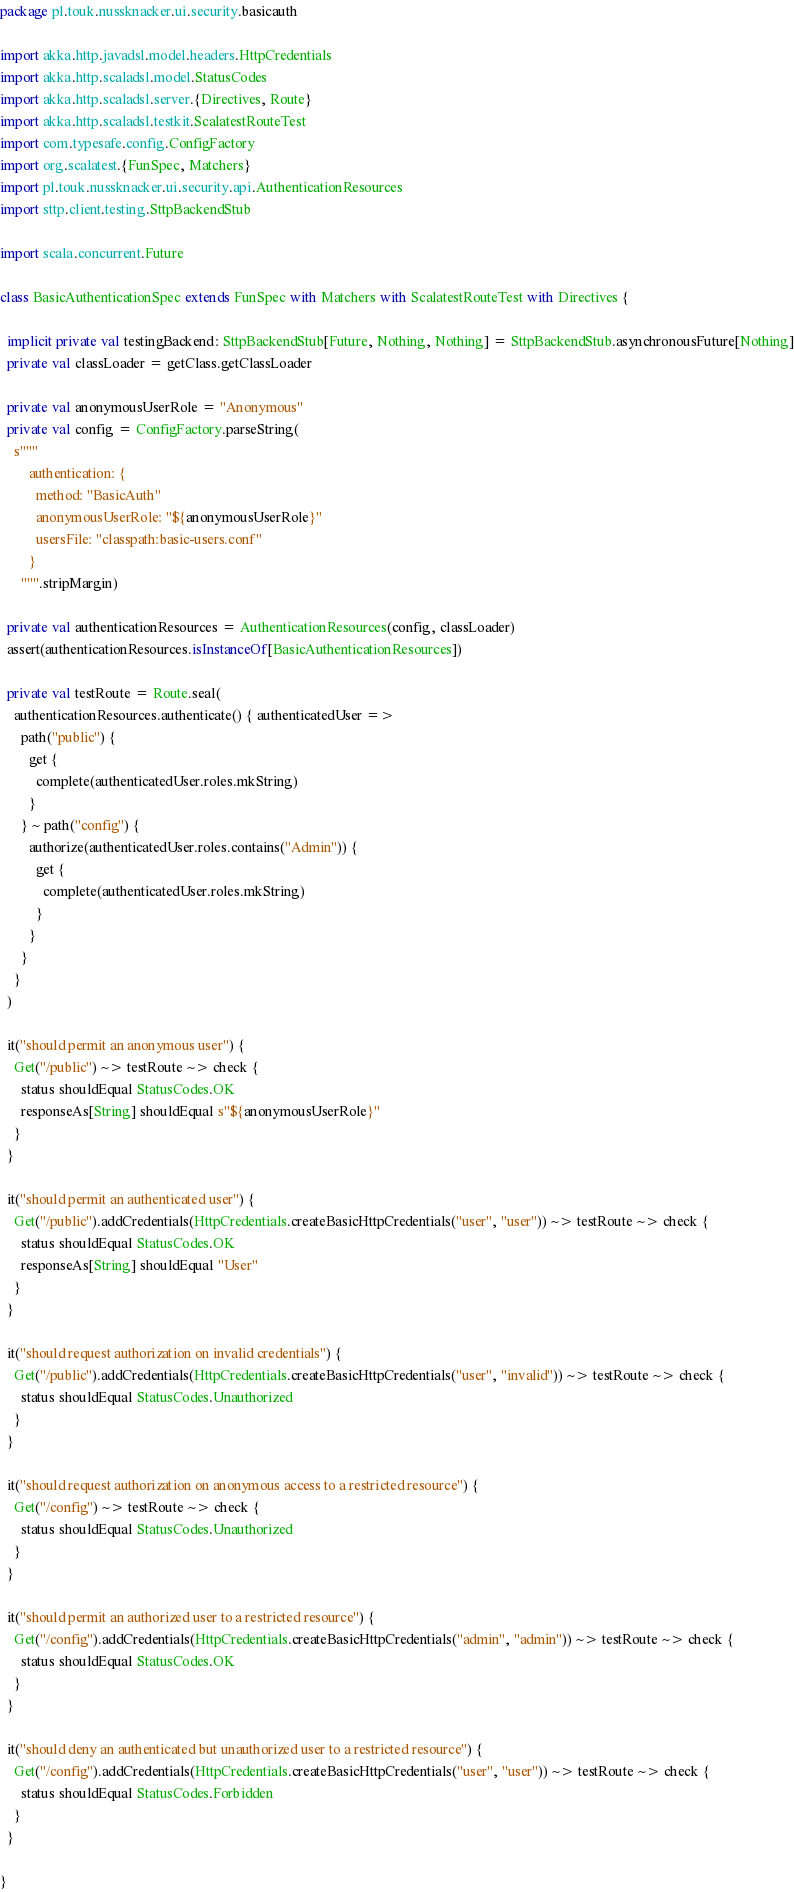Convert code to text. <code><loc_0><loc_0><loc_500><loc_500><_Scala_>package pl.touk.nussknacker.ui.security.basicauth

import akka.http.javadsl.model.headers.HttpCredentials
import akka.http.scaladsl.model.StatusCodes
import akka.http.scaladsl.server.{Directives, Route}
import akka.http.scaladsl.testkit.ScalatestRouteTest
import com.typesafe.config.ConfigFactory
import org.scalatest.{FunSpec, Matchers}
import pl.touk.nussknacker.ui.security.api.AuthenticationResources
import sttp.client.testing.SttpBackendStub

import scala.concurrent.Future

class BasicAuthenticationSpec extends FunSpec with Matchers with ScalatestRouteTest with Directives {

  implicit private val testingBackend: SttpBackendStub[Future, Nothing, Nothing] = SttpBackendStub.asynchronousFuture[Nothing]
  private val classLoader = getClass.getClassLoader

  private val anonymousUserRole = "Anonymous"
  private val config = ConfigFactory.parseString(
    s"""
        authentication: {
          method: "BasicAuth"
          anonymousUserRole: "${anonymousUserRole}"
          usersFile: "classpath:basic-users.conf"
        }
      """.stripMargin)

  private val authenticationResources = AuthenticationResources(config, classLoader)
  assert(authenticationResources.isInstanceOf[BasicAuthenticationResources])

  private val testRoute = Route.seal(
    authenticationResources.authenticate() { authenticatedUser =>
      path("public") {
        get {
          complete(authenticatedUser.roles.mkString)
        }
      } ~ path("config") {
        authorize(authenticatedUser.roles.contains("Admin")) {
          get {
            complete(authenticatedUser.roles.mkString)
          }
        }
      }
    }
  )

  it("should permit an anonymous user") {
    Get("/public") ~> testRoute ~> check {
      status shouldEqual StatusCodes.OK
      responseAs[String] shouldEqual s"${anonymousUserRole}"
    }
  }

  it("should permit an authenticated user") {
    Get("/public").addCredentials(HttpCredentials.createBasicHttpCredentials("user", "user")) ~> testRoute ~> check {
      status shouldEqual StatusCodes.OK
      responseAs[String] shouldEqual "User"
    }
  }

  it("should request authorization on invalid credentials") {
    Get("/public").addCredentials(HttpCredentials.createBasicHttpCredentials("user", "invalid")) ~> testRoute ~> check {
      status shouldEqual StatusCodes.Unauthorized
    }
  }

  it("should request authorization on anonymous access to a restricted resource") {
    Get("/config") ~> testRoute ~> check {
      status shouldEqual StatusCodes.Unauthorized
    }
  }

  it("should permit an authorized user to a restricted resource") {
    Get("/config").addCredentials(HttpCredentials.createBasicHttpCredentials("admin", "admin")) ~> testRoute ~> check {
      status shouldEqual StatusCodes.OK
    }
  }

  it("should deny an authenticated but unauthorized user to a restricted resource") {
    Get("/config").addCredentials(HttpCredentials.createBasicHttpCredentials("user", "user")) ~> testRoute ~> check {
      status shouldEqual StatusCodes.Forbidden
    }
  }

}
</code> 